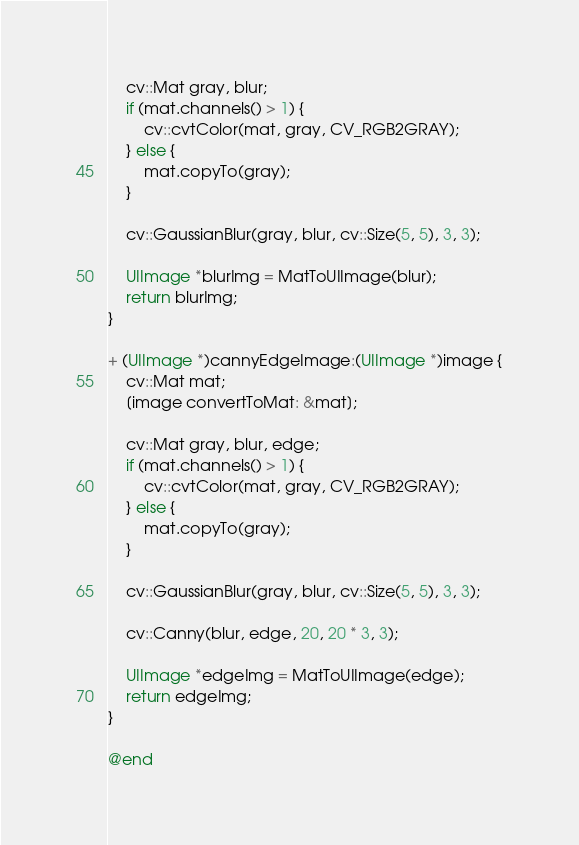Convert code to text. <code><loc_0><loc_0><loc_500><loc_500><_ObjectiveC_>
    cv::Mat gray, blur;
    if (mat.channels() > 1) {
        cv::cvtColor(mat, gray, CV_RGB2GRAY);
    } else {
        mat.copyTo(gray);
    }

    cv::GaussianBlur(gray, blur, cv::Size(5, 5), 3, 3);

    UIImage *blurImg = MatToUIImage(blur);
    return blurImg;
}

+ (UIImage *)cannyEdgeImage:(UIImage *)image {
    cv::Mat mat;
    [image convertToMat: &mat];

    cv::Mat gray, blur, edge;
    if (mat.channels() > 1) {
        cv::cvtColor(mat, gray, CV_RGB2GRAY);
    } else {
        mat.copyTo(gray);
    }

    cv::GaussianBlur(gray, blur, cv::Size(5, 5), 3, 3);

    cv::Canny(blur, edge, 20, 20 * 3, 3);

    UIImage *edgeImg = MatToUIImage(edge);
    return edgeImg;
}

@end
</code> 